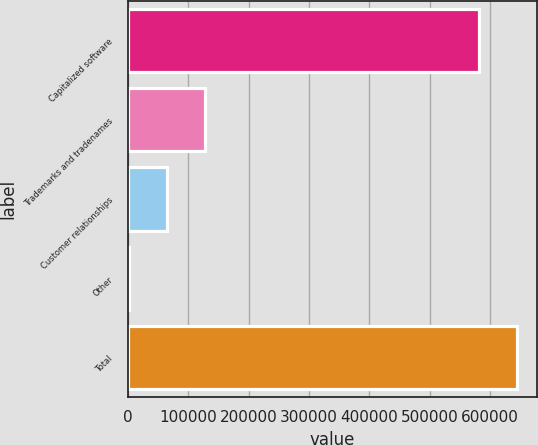<chart> <loc_0><loc_0><loc_500><loc_500><bar_chart><fcel>Capitalized software<fcel>Trademarks and tradenames<fcel>Customer relationships<fcel>Other<fcel>Total<nl><fcel>581874<fcel>127065<fcel>64434<fcel>1803<fcel>644505<nl></chart> 